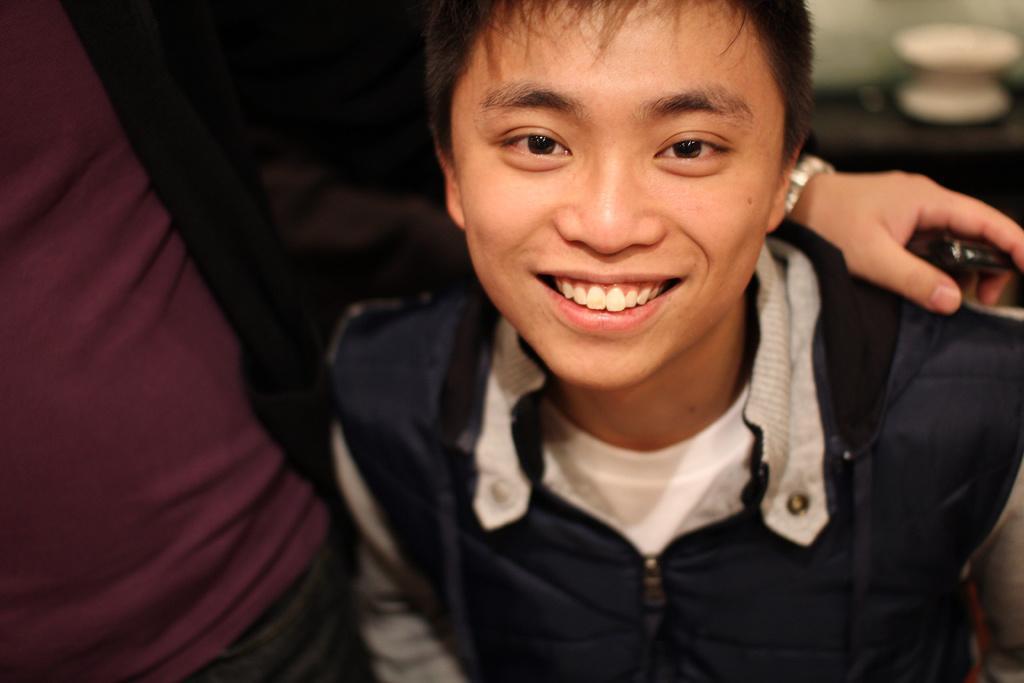How would you summarize this image in a sentence or two? This image is taken indoors. In this image the background is a little blurred and there is an object on the table. On the left side of the image there is a person. On the right side of the image there is a man and he is with a smiling face. 